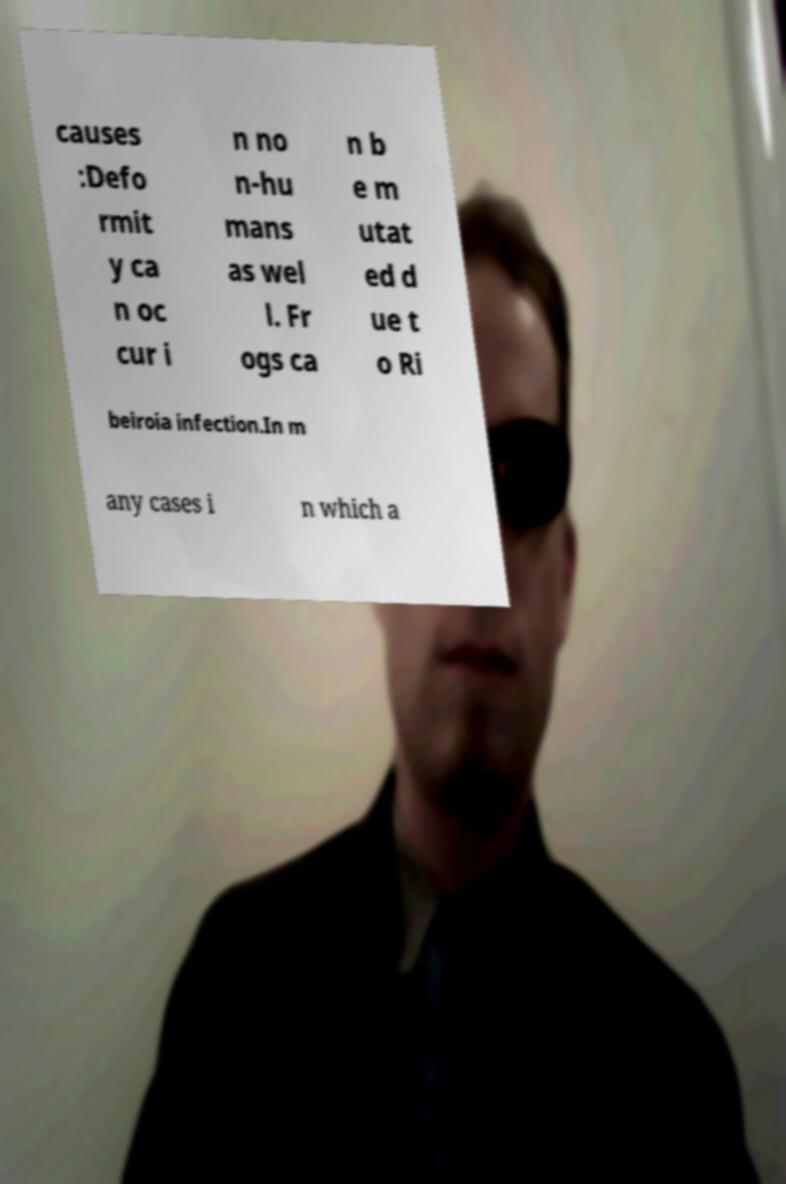Could you extract and type out the text from this image? causes :Defo rmit y ca n oc cur i n no n-hu mans as wel l. Fr ogs ca n b e m utat ed d ue t o Ri beiroia infection.In m any cases i n which a 